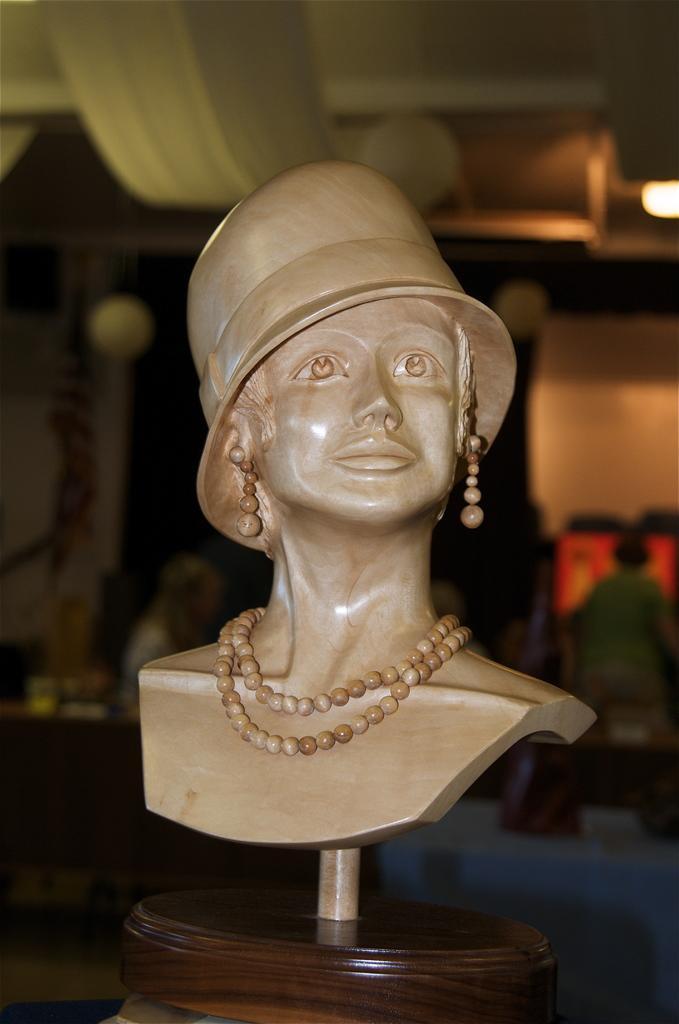How would you summarize this image in a sentence or two? There is a sculpture of a person wearing hat, earrings and necklace. 